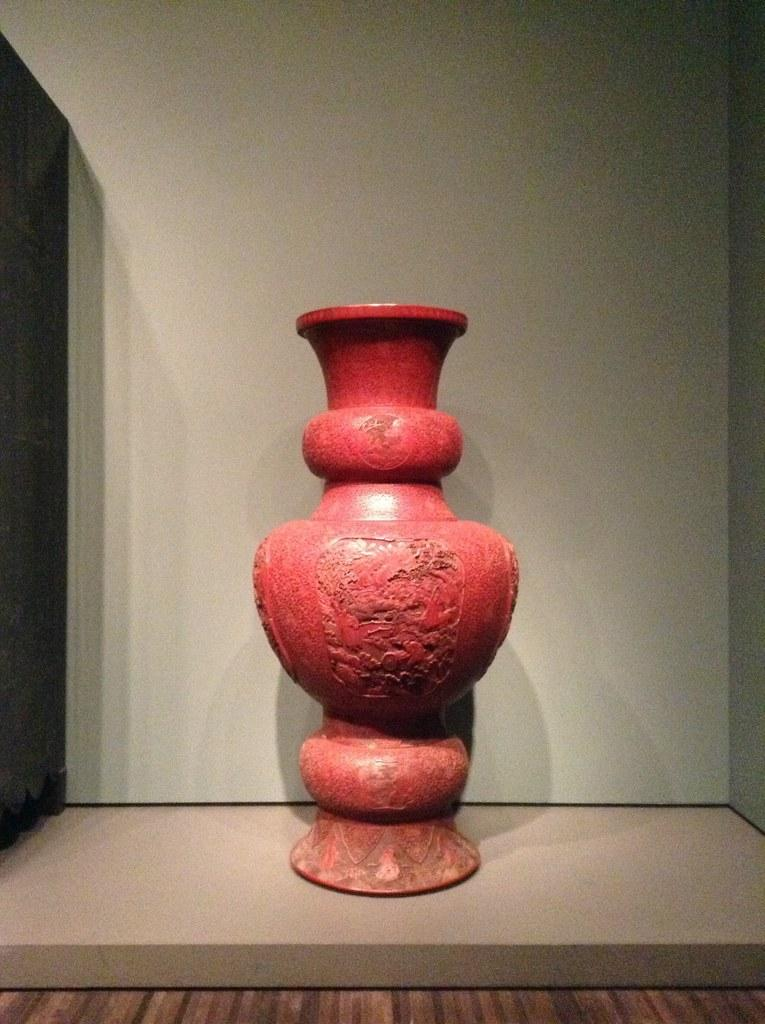What color is the vase in the image? The vase in the image is red. Where is the vase located in the image? The vase is placed on a wooden plank. How many horses are visible in the image? There are no horses present in the image. What type of comfort does the crib provide in the image? There is no crib present in the image. 